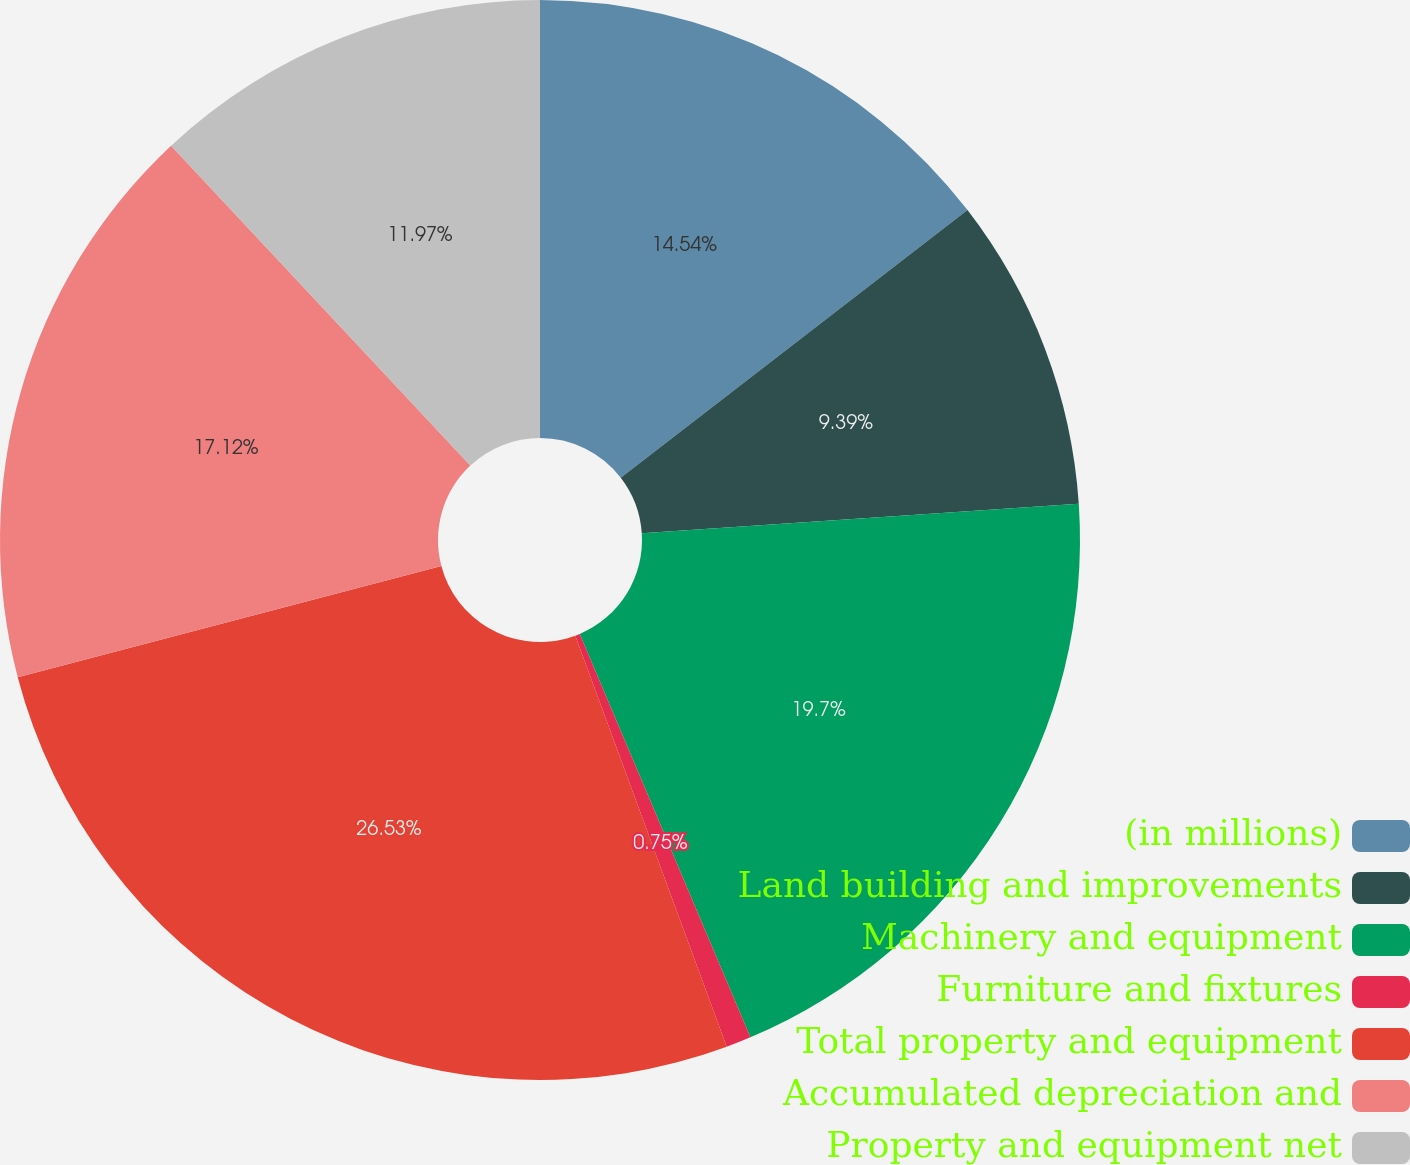Convert chart. <chart><loc_0><loc_0><loc_500><loc_500><pie_chart><fcel>(in millions)<fcel>Land building and improvements<fcel>Machinery and equipment<fcel>Furniture and fixtures<fcel>Total property and equipment<fcel>Accumulated depreciation and<fcel>Property and equipment net<nl><fcel>14.54%<fcel>9.39%<fcel>19.7%<fcel>0.75%<fcel>26.53%<fcel>17.12%<fcel>11.97%<nl></chart> 